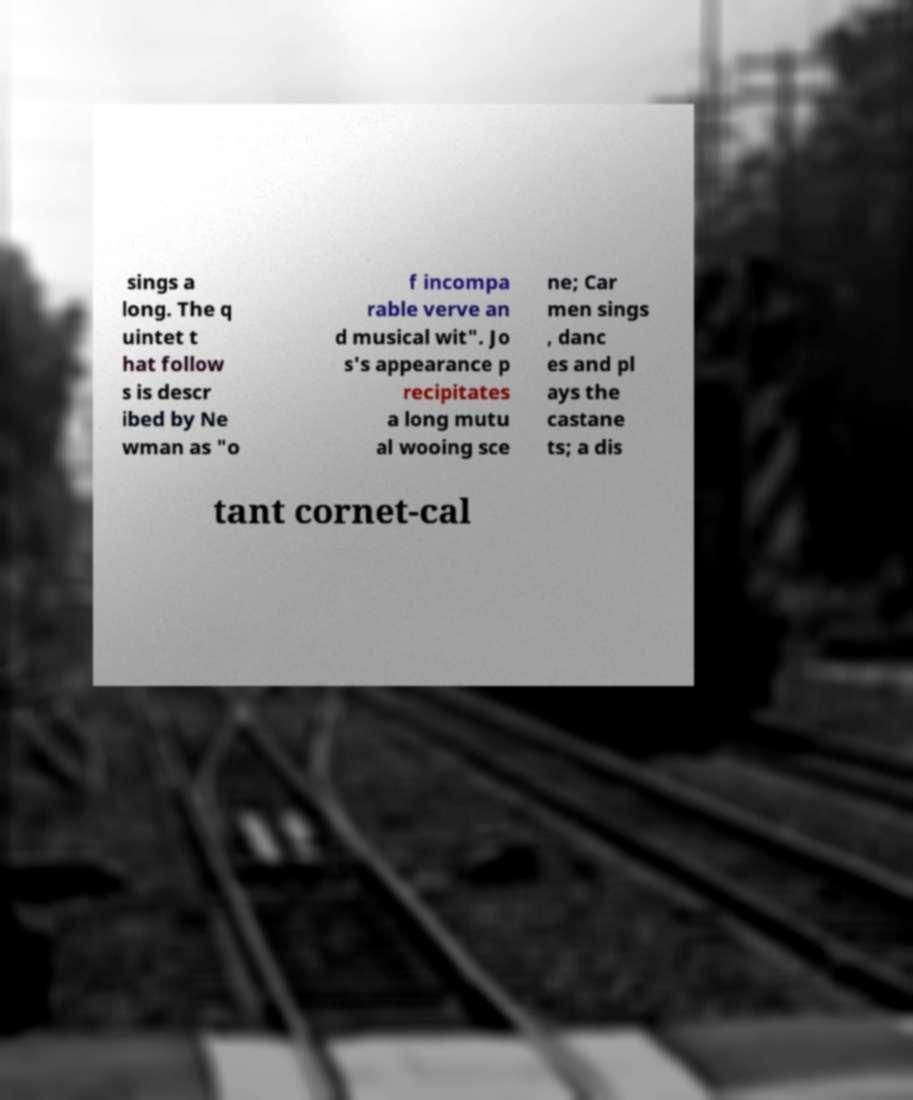Can you accurately transcribe the text from the provided image for me? sings a long. The q uintet t hat follow s is descr ibed by Ne wman as "o f incompa rable verve an d musical wit". Jo s's appearance p recipitates a long mutu al wooing sce ne; Car men sings , danc es and pl ays the castane ts; a dis tant cornet-cal 